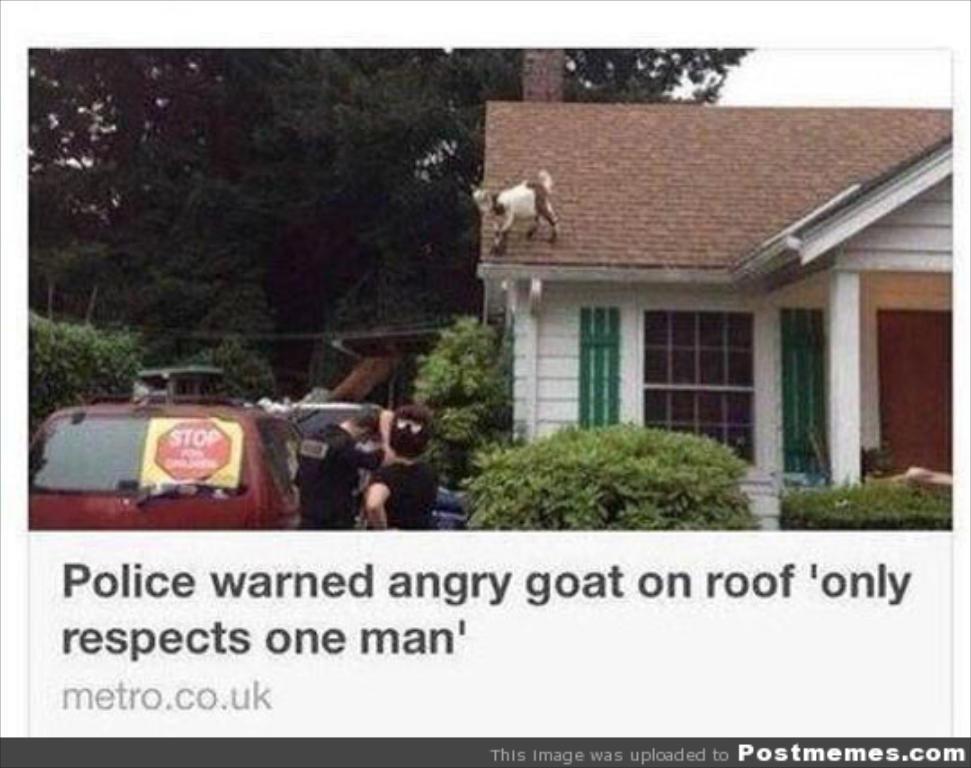In one or two sentences, can you explain what this image depicts? In this image we can see a house. A goat is standing on the top of the house. There are many trees and plants in the image. There is a vehicle and two persons are standing near to it in the image. There is some text which is written on the image. 